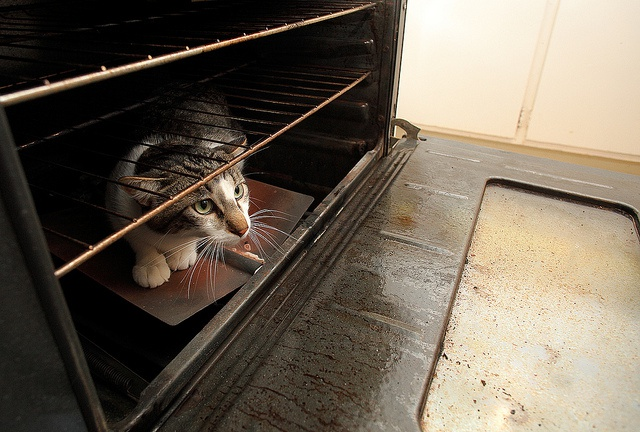Describe the objects in this image and their specific colors. I can see oven in black, maroon, and gray tones and cat in black, maroon, and gray tones in this image. 